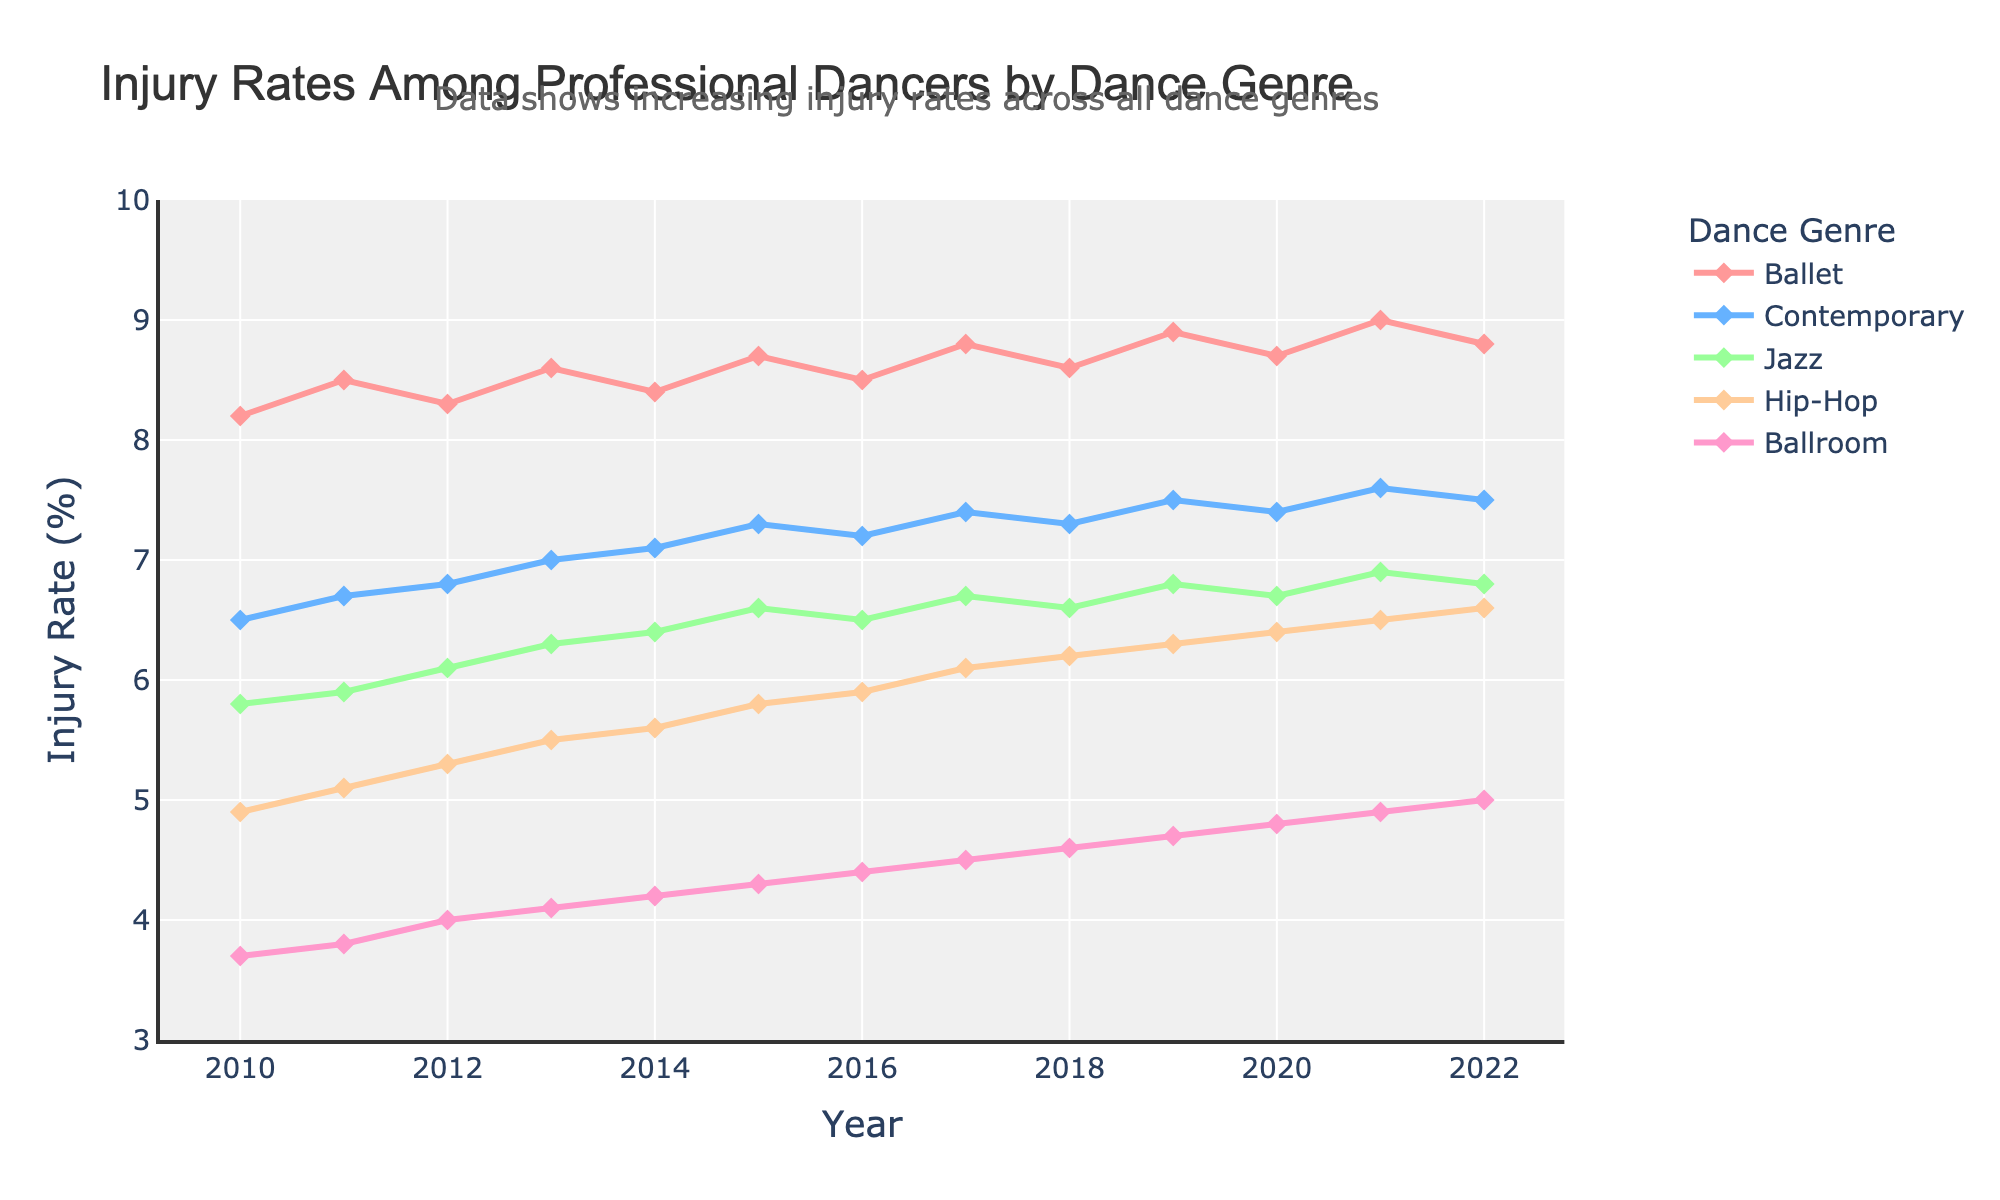What was the injury rate for Jazz dancers in 2015? Look at the line representing Jazz in 2015.
Answer: 6.6 Which dance genre had the highest injury rate in 2022? Examine the lines for all dance genres in 2022 and identify the one with the highest value.
Answer: Ballet Between which years did Hip-Hop see the most significant increase in injury rates? Identify the year pairs that show the largest rise in the Hip-Hop line graph.
Answer: 2012 and 2013 What's the difference in injury rates between Ballet and Contemporary dancers in 2021? Subtract the injury rate of Contemporary dancers from that of Ballet dancers in 2021.
Answer: 1.4 Which dance genre shows a consistent increase in injury rates from 2010 to 2022? Observe the trends for all dance genres and identify which one steadily rises over the years.
Answer: Contemporary How do the injury rates of Ballroom dancers change from 2016 to 2022? Examine the progression of the Ballroom line from 2016 to 2022.
Answer: Steady increase What's the average injury rate for Contemporary dancers from 2010 to 2022? Sum the injury rates for Contemporary dancers from 2010 to 2022 and divide by 13 (number of years). {6.5+6.7+6.8+7.0+7.1+7.3+7.2+7.4+7.3+7.5+7.4+7.6+7.5} / 13 = 7.08 (rounded to 2 decimals)
Answer: 7.08 Which year had the lowest injury rate for Ballroom dancers, and what was the rate? Identify the lowest point on the Ballroom line and note the corresponding year and rate.
Answer: 2010, 3.7 Compare the injury rates of Jazz in 2014 and 2020. Which year had a higher rate? By how much? Compare the points for Jazz in 2014 and 2020 on the graph and calculate the difference. 2020 rate is 6.7, 2014 rate is 6.4; Difference = 6.7 - 6.4
Answer: 2020, by 0.3 Do Ballet dancers consistently have the highest injury rates compared to other genres from 2010 to 2022? Observe the Ballet line and compare its values with other genres for each year from 2010 to 2022.
Answer: Yes 